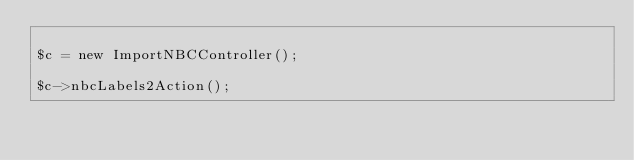Convert code to text. <code><loc_0><loc_0><loc_500><loc_500><_PHP_>
$c = new ImportNBCController();

$c->nbcLabels2Action();
</code> 